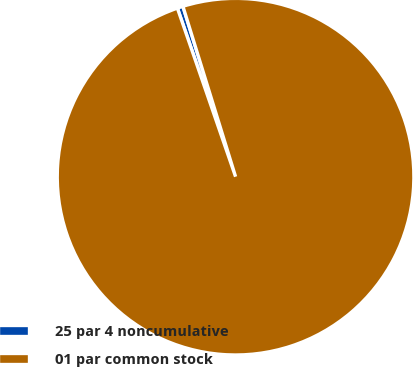Convert chart. <chart><loc_0><loc_0><loc_500><loc_500><pie_chart><fcel>25 par 4 noncumulative<fcel>01 par common stock<nl><fcel>0.52%<fcel>99.48%<nl></chart> 